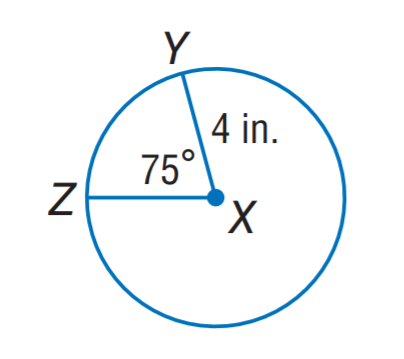Question: Find the length of \widehat Z Y. Round to the nearest hundredth.
Choices:
A. 3.76
B. 4.64
C. 5.24
D. 7.28
Answer with the letter. Answer: C 